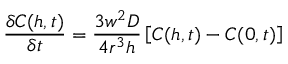<formula> <loc_0><loc_0><loc_500><loc_500>\frac { \delta C ( h , t ) } { \delta t } = \frac { 3 w ^ { 2 } D } { 4 r ^ { 3 } h } \left [ C ( h , t ) - C ( 0 , t ) \right ]</formula> 